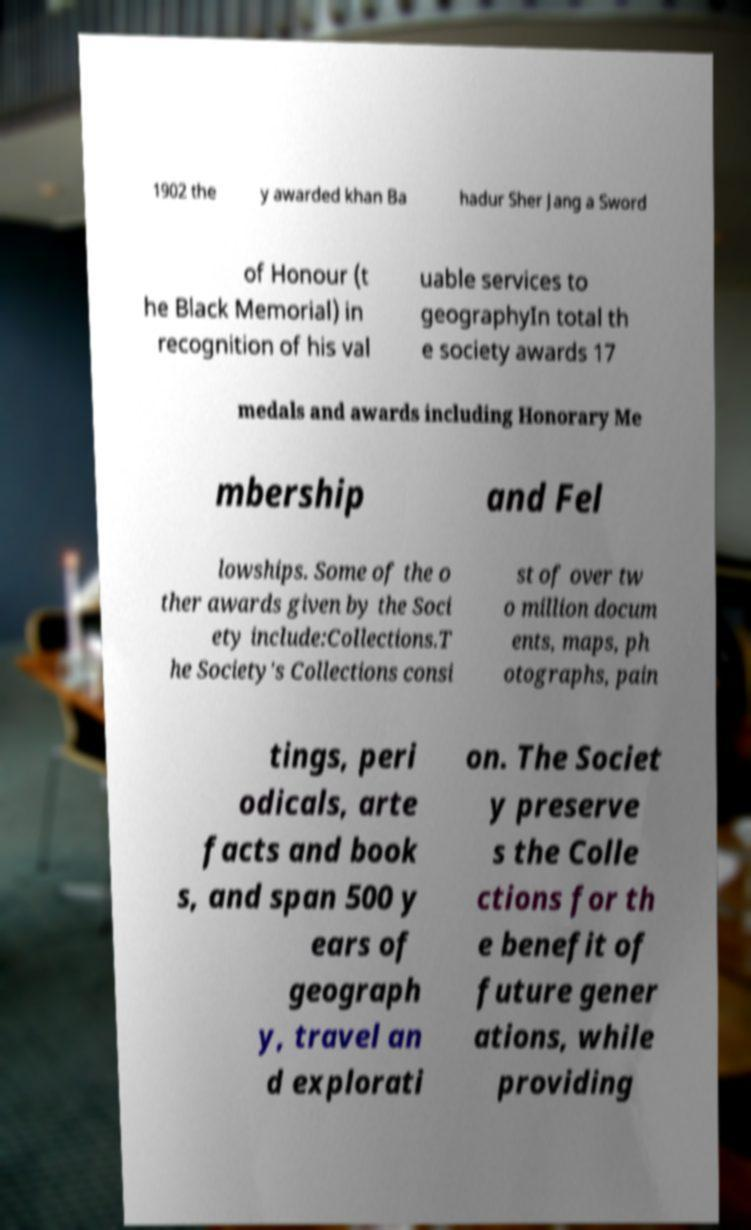Please identify and transcribe the text found in this image. 1902 the y awarded khan Ba hadur Sher Jang a Sword of Honour (t he Black Memorial) in recognition of his val uable services to geographyIn total th e society awards 17 medals and awards including Honorary Me mbership and Fel lowships. Some of the o ther awards given by the Soci ety include:Collections.T he Society's Collections consi st of over tw o million docum ents, maps, ph otographs, pain tings, peri odicals, arte facts and book s, and span 500 y ears of geograph y, travel an d explorati on. The Societ y preserve s the Colle ctions for th e benefit of future gener ations, while providing 